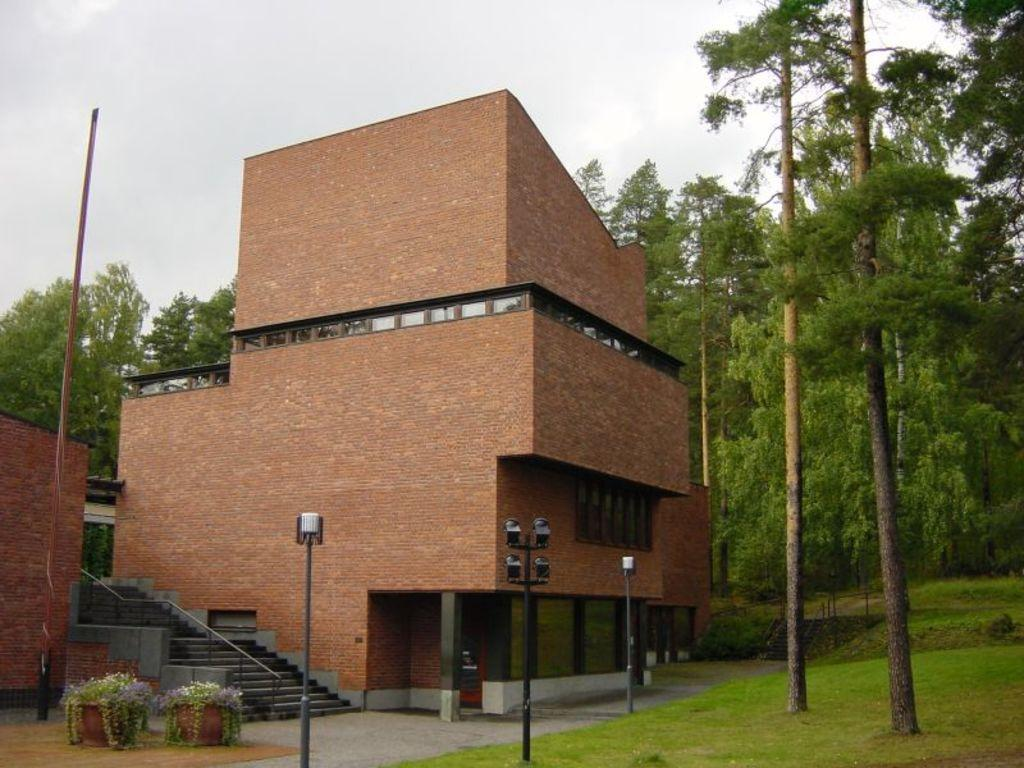What type of structure can be seen in the image? There is a building in the image. Can you describe the position of the second building in relation to the first building? There is another building in front of the first building. What other objects can be seen in the image? There are poles, a flower pot, plants, and trees in the image. What is visible at the top of the image? The sky is visible at the top of the image. What type of boot is being worn by the authority figure in the image? There is no authority figure or boot present in the image. 